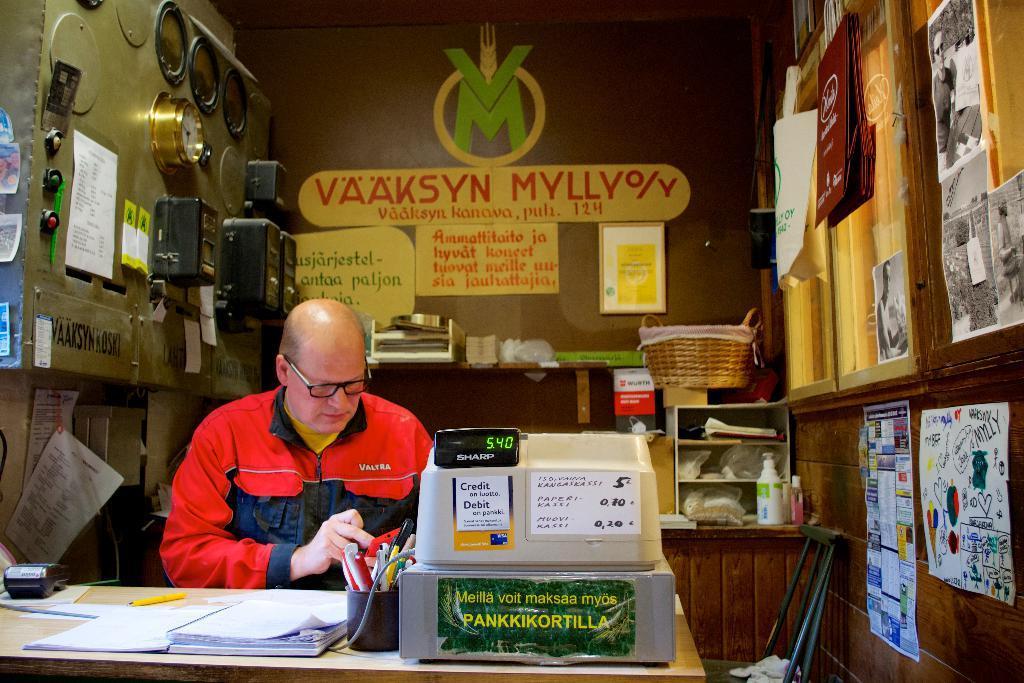How would you summarize this image in a sentence or two? In this picture, we can see a person, and table with some objects on it, like machine, paper, cup with some objects in it, and we can see the wall, and some posters with some text and some images on it, clocks, and some objects attached to it, we can see a chair. 